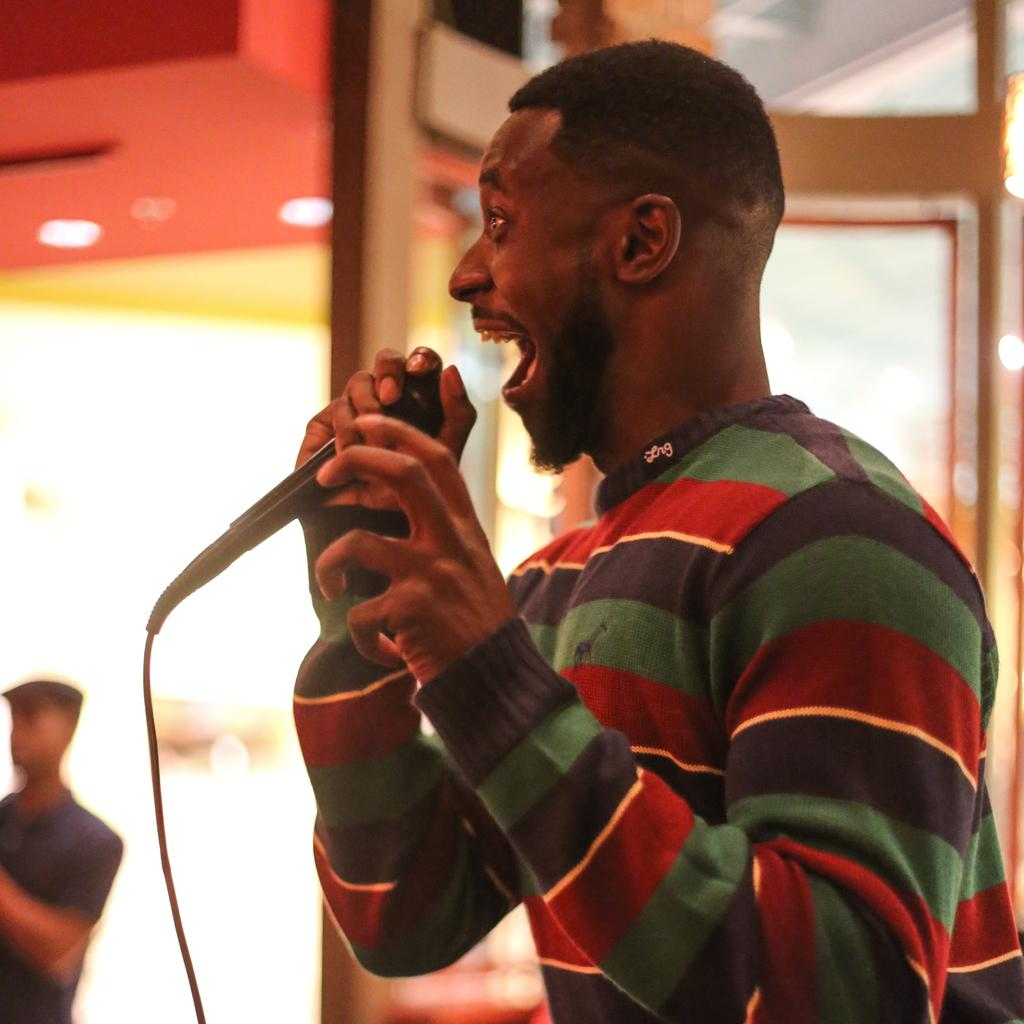What is the man in the image doing? The man is singing in the image. What is the man holding while singing? The man is holding a microphone. What type of clothing is the man wearing? The man is wearing a t-shirt. What can be seen in the background of the image? There are doors in the background of the image. How many geese are present in the image? There are no geese present in the image. What type of fang can be seen in the man's mouth in the image? The man is not displaying any fangs in the image. 